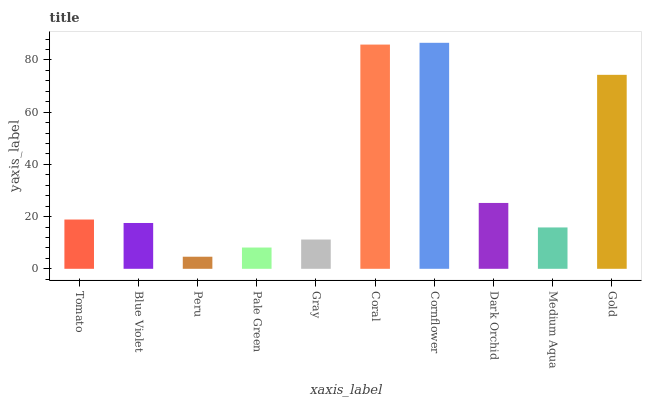Is Peru the minimum?
Answer yes or no. Yes. Is Cornflower the maximum?
Answer yes or no. Yes. Is Blue Violet the minimum?
Answer yes or no. No. Is Blue Violet the maximum?
Answer yes or no. No. Is Tomato greater than Blue Violet?
Answer yes or no. Yes. Is Blue Violet less than Tomato?
Answer yes or no. Yes. Is Blue Violet greater than Tomato?
Answer yes or no. No. Is Tomato less than Blue Violet?
Answer yes or no. No. Is Tomato the high median?
Answer yes or no. Yes. Is Blue Violet the low median?
Answer yes or no. Yes. Is Coral the high median?
Answer yes or no. No. Is Coral the low median?
Answer yes or no. No. 